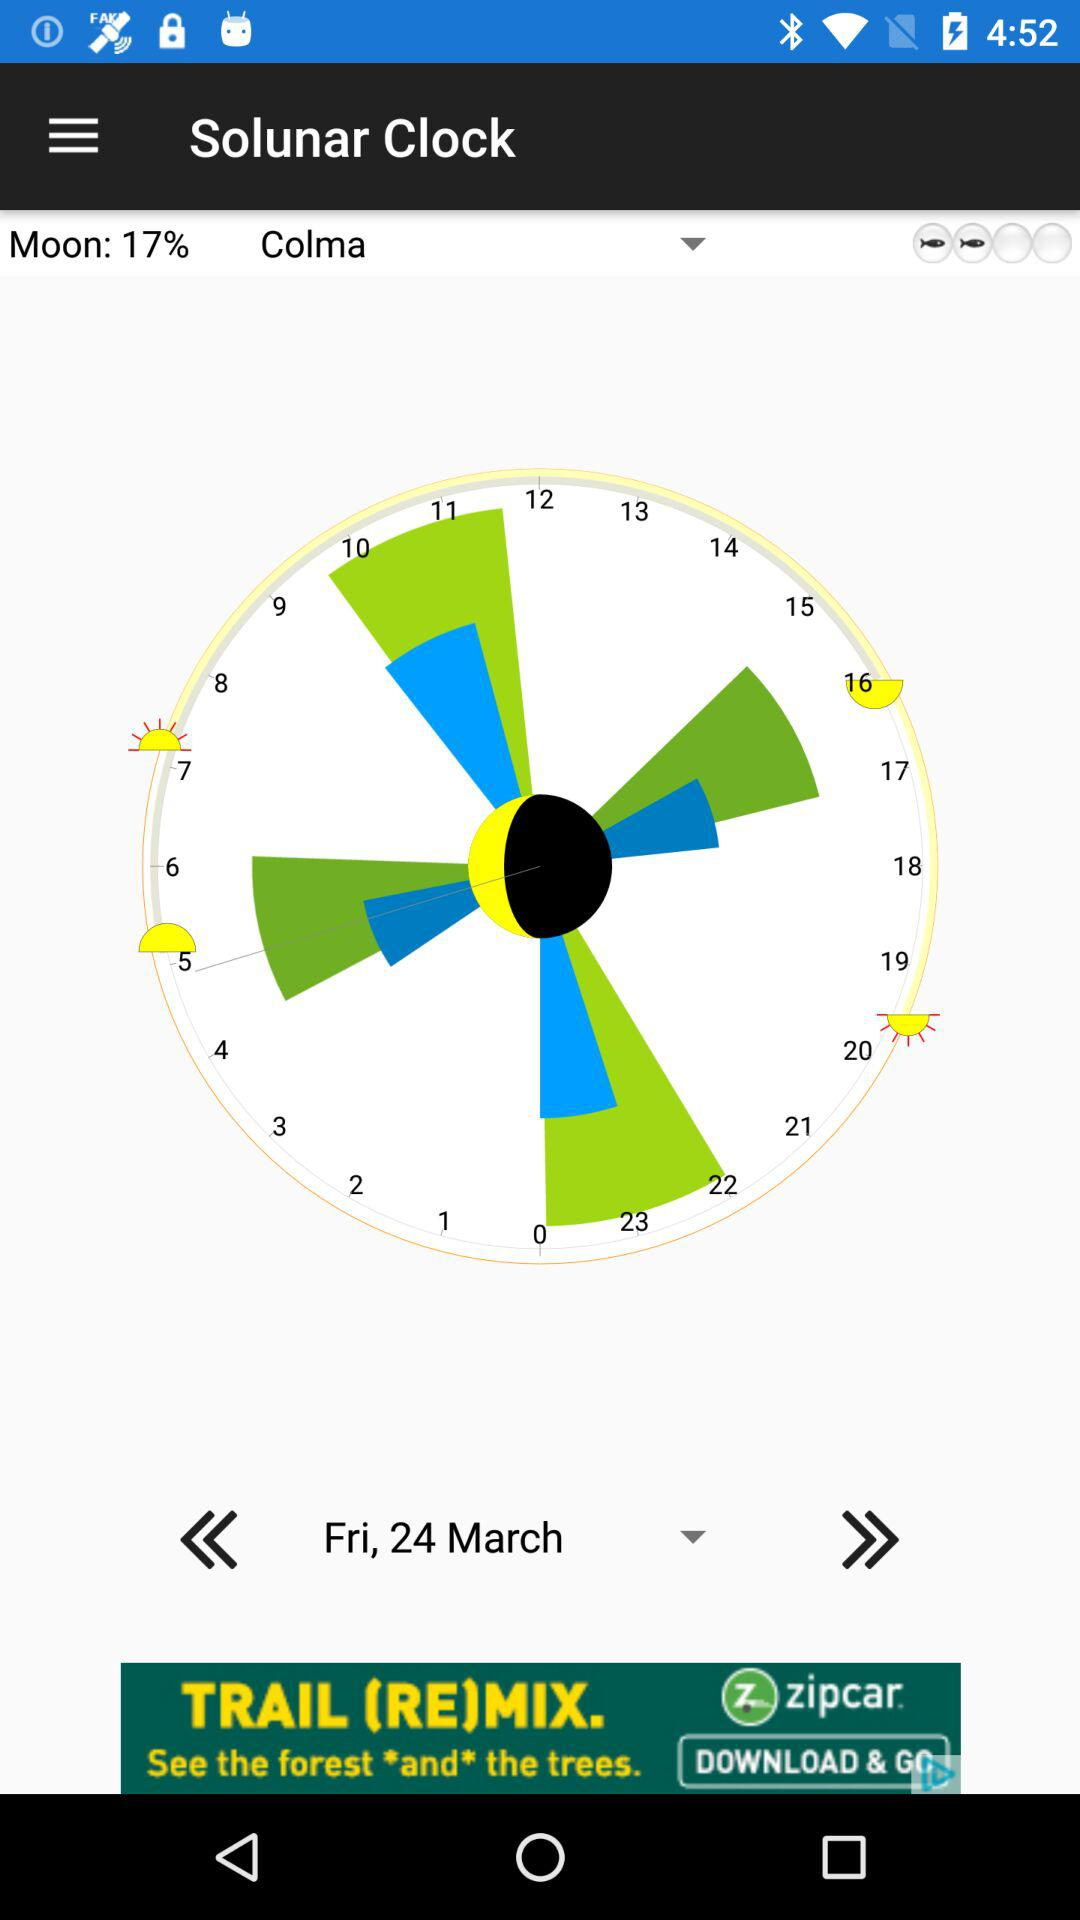What's the percentage for "Moon"? The percentage for "Moon" is 17. 